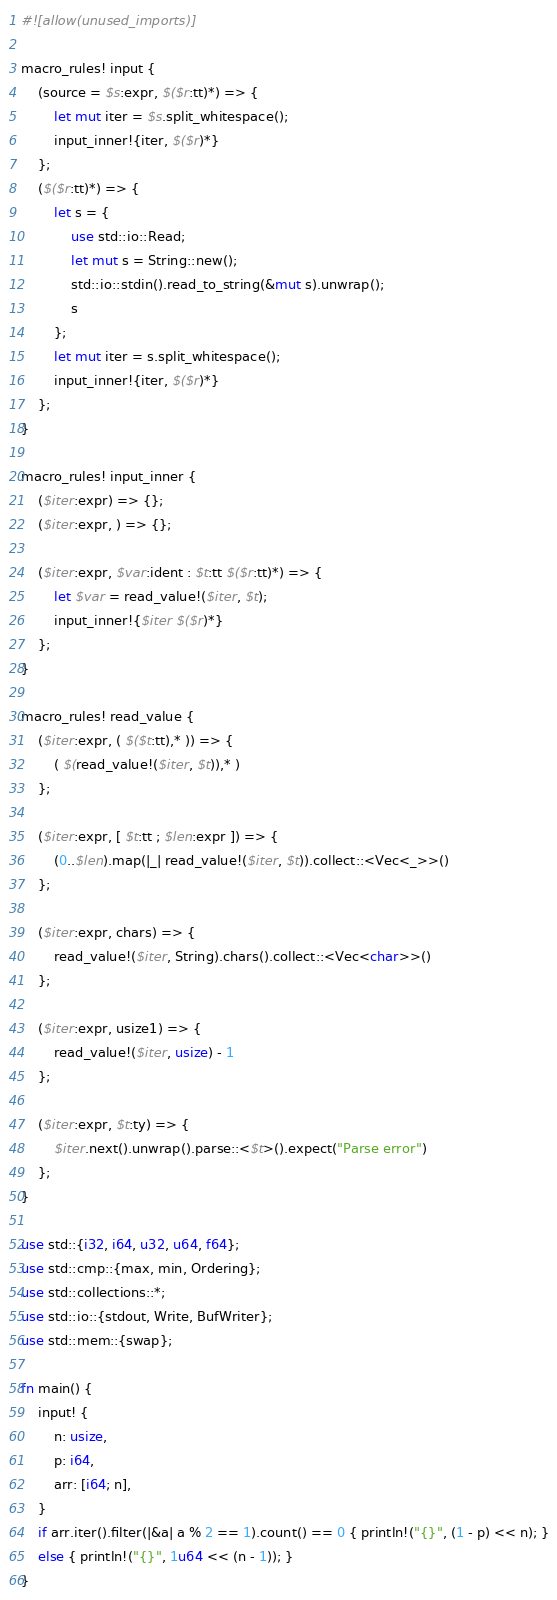Convert code to text. <code><loc_0><loc_0><loc_500><loc_500><_Rust_>#![allow(unused_imports)]

macro_rules! input {
    (source = $s:expr, $($r:tt)*) => {
        let mut iter = $s.split_whitespace();
        input_inner!{iter, $($r)*}
    };
    ($($r:tt)*) => {
        let s = {
            use std::io::Read;
            let mut s = String::new();
            std::io::stdin().read_to_string(&mut s).unwrap();
            s
        };
        let mut iter = s.split_whitespace();
        input_inner!{iter, $($r)*}
    };
}

macro_rules! input_inner {
    ($iter:expr) => {};
    ($iter:expr, ) => {};

    ($iter:expr, $var:ident : $t:tt $($r:tt)*) => {
        let $var = read_value!($iter, $t);
        input_inner!{$iter $($r)*}
    };
}

macro_rules! read_value {
    ($iter:expr, ( $($t:tt),* )) => {
        ( $(read_value!($iter, $t)),* )
    };

    ($iter:expr, [ $t:tt ; $len:expr ]) => {
        (0..$len).map(|_| read_value!($iter, $t)).collect::<Vec<_>>()
    };

    ($iter:expr, chars) => {
        read_value!($iter, String).chars().collect::<Vec<char>>()
    };

    ($iter:expr, usize1) => {
        read_value!($iter, usize) - 1
    };

    ($iter:expr, $t:ty) => {
        $iter.next().unwrap().parse::<$t>().expect("Parse error")
    };
}

use std::{i32, i64, u32, u64, f64};
use std::cmp::{max, min, Ordering};
use std::collections::*;
use std::io::{stdout, Write, BufWriter};
use std::mem::{swap};

fn main() {
    input! {
        n: usize,
        p: i64,
        arr: [i64; n],
    }
    if arr.iter().filter(|&a| a % 2 == 1).count() == 0 { println!("{}", (1 - p) << n); }
    else { println!("{}", 1u64 << (n - 1)); }
}
</code> 